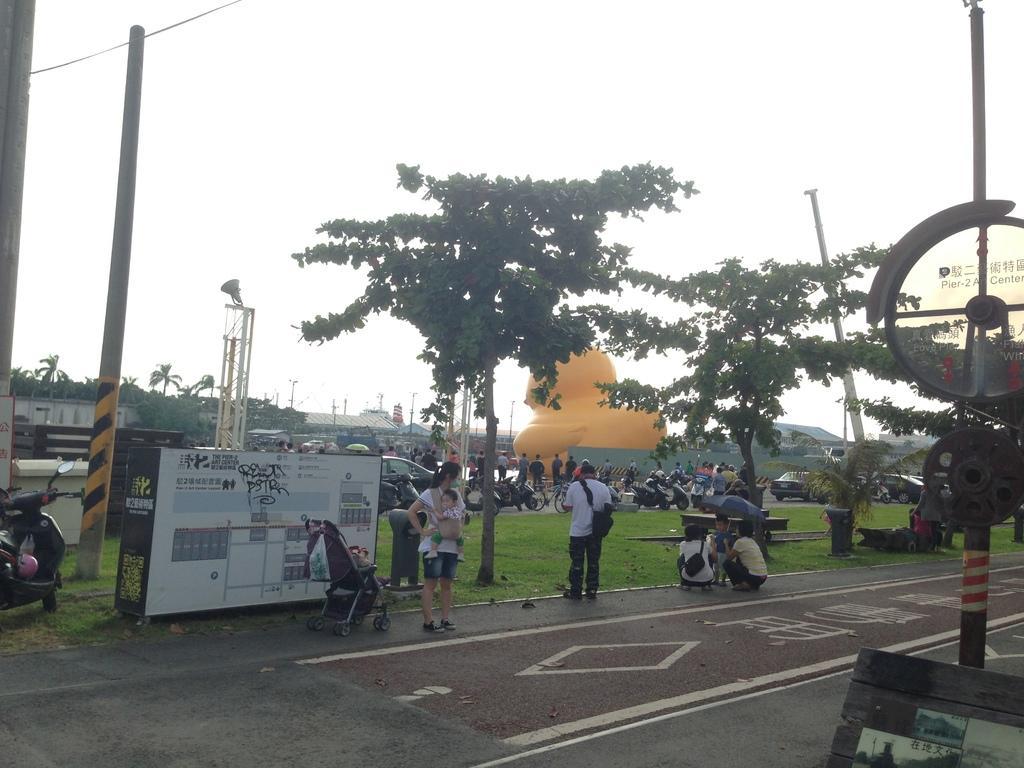How would you summarize this image in a sentence or two? In this picture we can see some people are standing and two people are in squat position. A woman is carrying a baby. On the left side of the woman there is a stroller, board and a motorbike. In front of the woman there is a pole with some objects. Behind the woman there is an inflatable object, poles, trees and there are some vehicles on the road. Behind the inflatable object, those are looking like houses. Behind the houses there is the sky. 